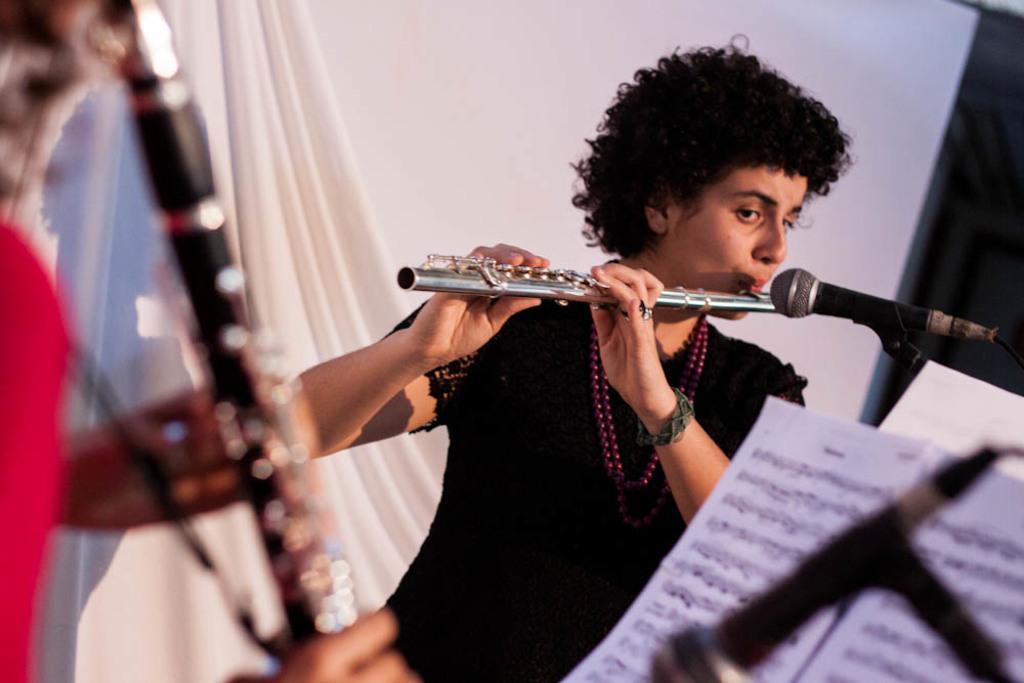How would you summarize this image in a sentence or two? In the image there is a woman playing a flute and in front of her there is a mic, behind the woman there is a wall and in the foreground there are music notations, an instrument and a mic. 